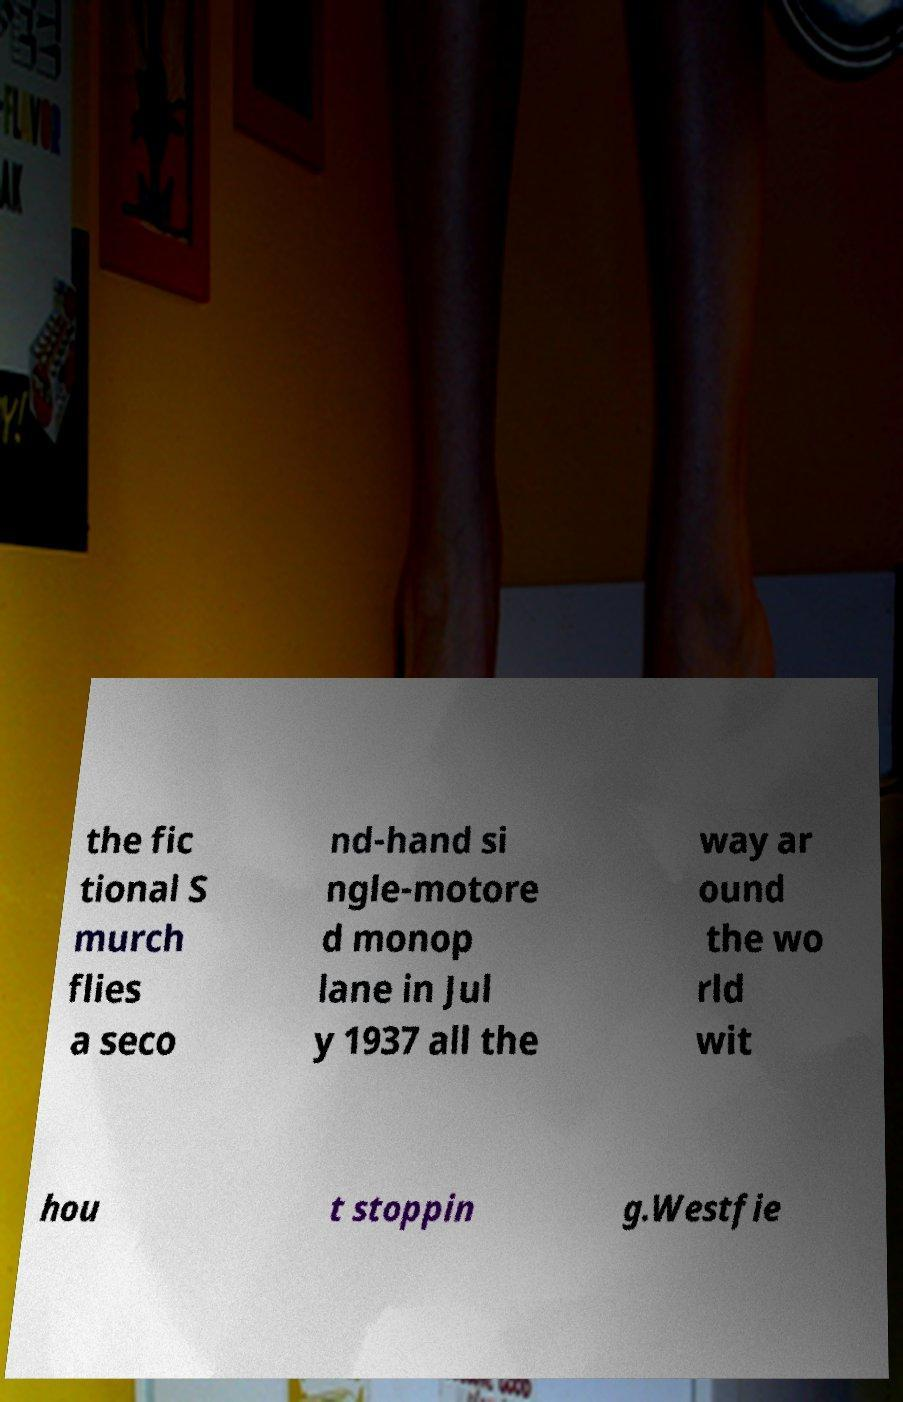Can you accurately transcribe the text from the provided image for me? the fic tional S murch flies a seco nd-hand si ngle-motore d monop lane in Jul y 1937 all the way ar ound the wo rld wit hou t stoppin g.Westfie 